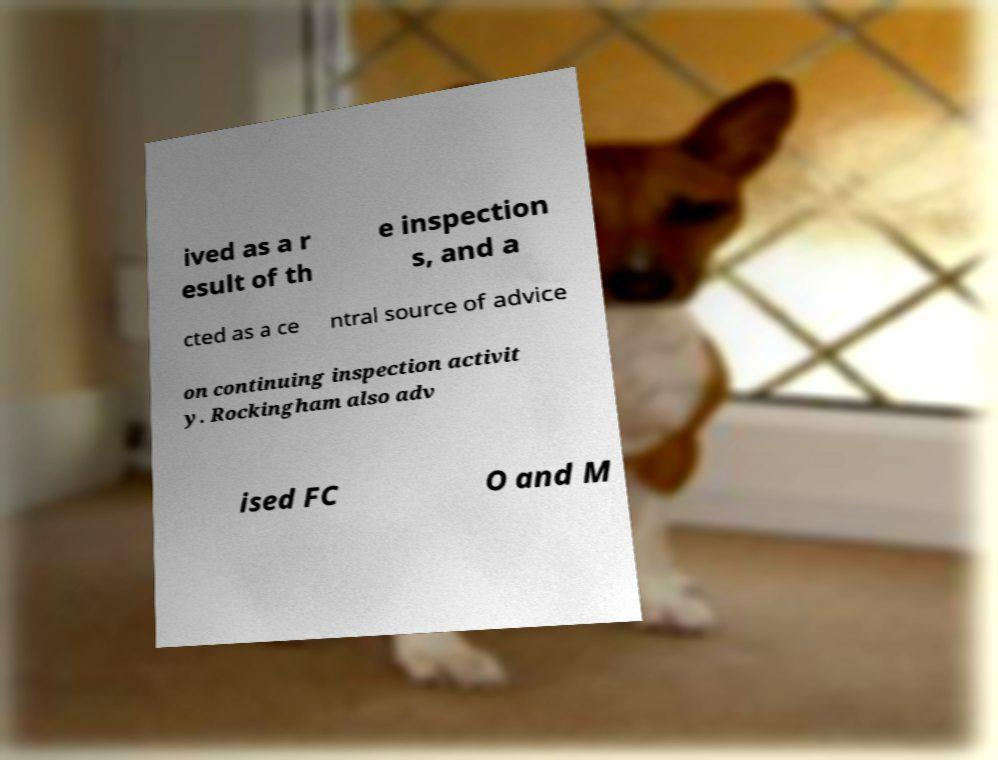Could you extract and type out the text from this image? ived as a r esult of th e inspection s, and a cted as a ce ntral source of advice on continuing inspection activit y. Rockingham also adv ised FC O and M 